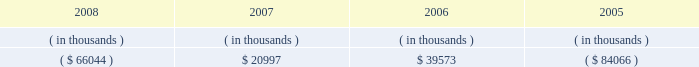Entergy mississippi , inc .
Management's financial discussion and analysis sources of capital entergy mississippi's sources to meet its capital requirements include : internally generated funds ; cash on hand ; debt or preferred stock issuances ; and bank financing under new or existing facilities .
Entergy mississippi may refinance or redeem debt and preferred stock prior to maturity , to the extent market conditions and interest and dividend rates are favorable .
All debt and common and preferred stock issuances by entergy mississippi require prior regulatory approval .
Preferred stock and debt issuances are also subject to issuance tests set forth in its corporate charter , bond indenture , and other agreements .
Entergy mississippi has sufficient capacity under these tests to meet its foreseeable capital needs .
Entergy mississippi has two separate credit facilities in the aggregate amount of $ 50 million and renewed both facilities through may 2009 .
Borrowings under the credit facilities may be secured by a security interest in entergy mississippi's accounts receivable .
No borrowings were outstanding under either credit facility as of december 31 , 2008 .
Entergy mississippi has obtained short-term borrowing authorization from the ferc under which it may borrow through march 31 , 2010 , up to the aggregate amount , at any one time outstanding , of $ 175 million .
See note 4 to the financial statements for further discussion of entergy mississippi's short-term borrowing limits .
Entergy mississippi has also obtained an order from the ferc authorizing long-term securities issuances .
The current long-term authorization extends through june 30 , 2009 .
Entergy mississippi's receivables from or ( payables to ) the money pool were as follows as of december 31 for each of the following years: .
In may 2007 , $ 6.6 million of entergy mississippi's receivable from the money pool was replaced by a note receivable from entergy new orleans .
See note 4 to the financial statements for a description of the money pool .
State and local rate regulation the rates that entergy mississippi charges for electricity significantly influence its financial position , results of operations , and liquidity .
Entergy mississippi is regulated and the rates charged to its customers are determined in regulatory proceedings .
A governmental agency , the mpsc , is primarily responsible for approval of the rates charged to customers .
Formula rate plan in march 2008 , entergy mississippi made its annual scheduled formula rate plan filing for the 2007 test year with the mpsc .
The filing showed that a $ 10.1 million increase in annual electric revenues is warranted .
In june 2008 , entergy mississippi reached a settlement with the mississippi public utilities staff that would result in a $ 3.8 million rate increase .
In january 2009 the mpsc rejected the settlement and left the current rates in effect .
Entergy mississippi appealed the mpsc's decision to the mississippi supreme court. .
What is the percent change in energy mississippi's receivables between 2006 and 2007? 
Computations: (20997 - 39573)
Answer: -18576.0. 